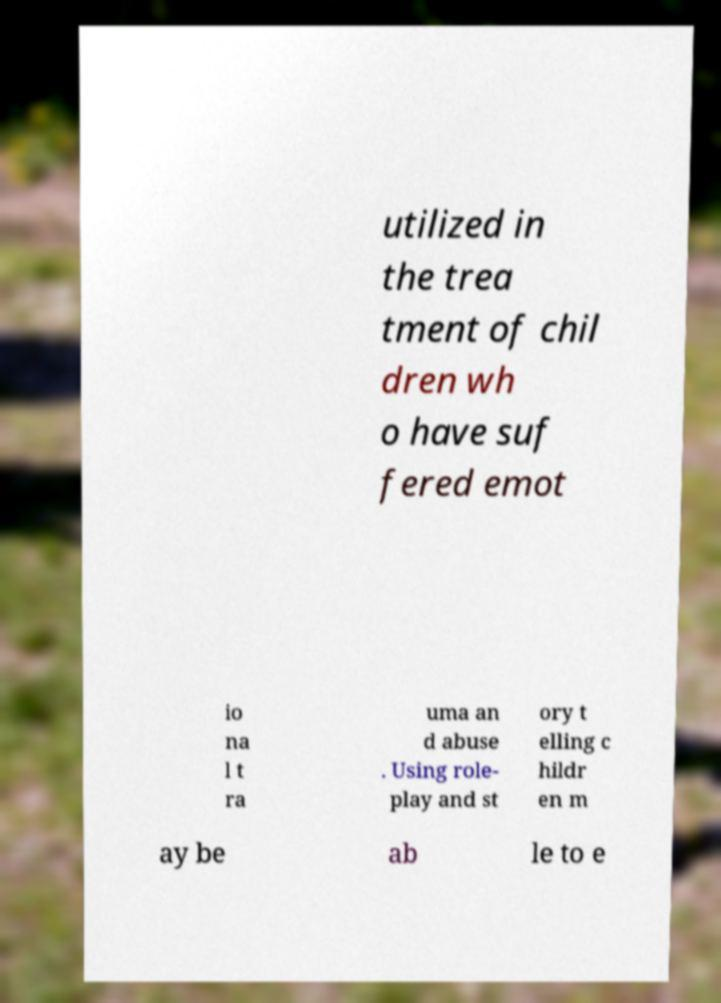Can you read and provide the text displayed in the image?This photo seems to have some interesting text. Can you extract and type it out for me? utilized in the trea tment of chil dren wh o have suf fered emot io na l t ra uma an d abuse . Using role- play and st ory t elling c hildr en m ay be ab le to e 